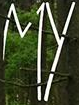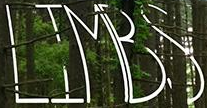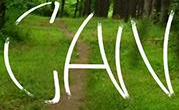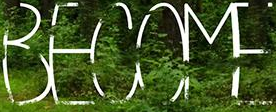What words are shown in these images in order, separated by a semicolon? MY; LIMBS; CAN; BECOME 